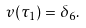<formula> <loc_0><loc_0><loc_500><loc_500>v ( \tau _ { 1 } ) = \delta _ { 6 } .</formula> 